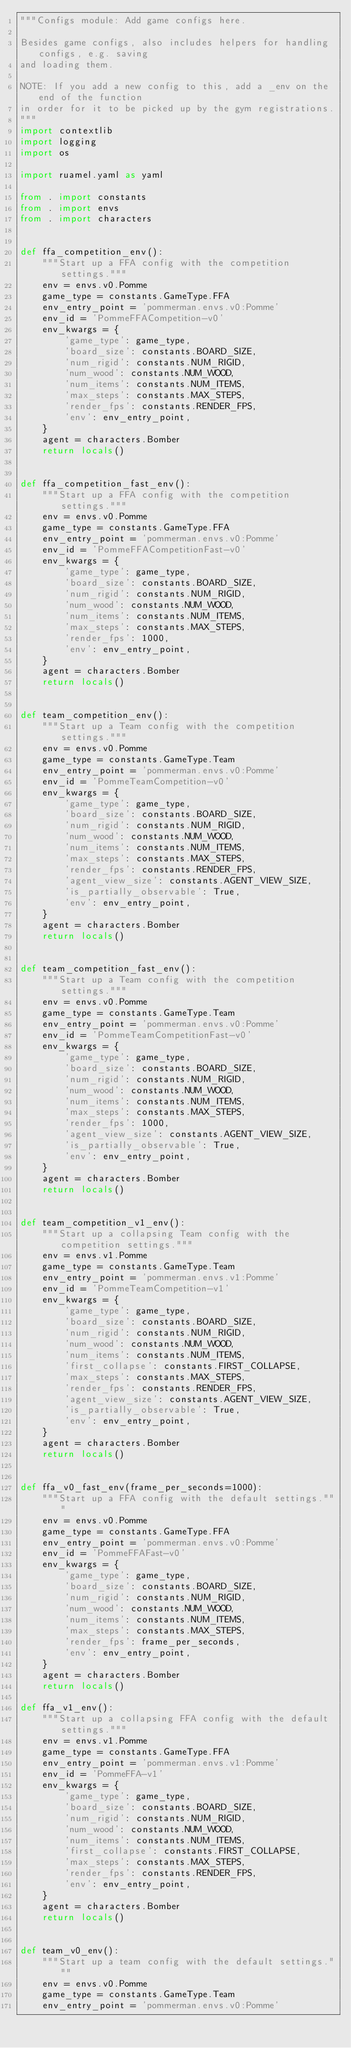<code> <loc_0><loc_0><loc_500><loc_500><_Python_>"""Configs module: Add game configs here.

Besides game configs, also includes helpers for handling configs, e.g. saving
and loading them.

NOTE: If you add a new config to this, add a _env on the end of the function
in order for it to be picked up by the gym registrations.
"""
import contextlib
import logging
import os

import ruamel.yaml as yaml

from . import constants
from . import envs
from . import characters


def ffa_competition_env():
    """Start up a FFA config with the competition settings."""
    env = envs.v0.Pomme
    game_type = constants.GameType.FFA
    env_entry_point = 'pommerman.envs.v0:Pomme'
    env_id = 'PommeFFACompetition-v0'
    env_kwargs = {
        'game_type': game_type,
        'board_size': constants.BOARD_SIZE,
        'num_rigid': constants.NUM_RIGID,
        'num_wood': constants.NUM_WOOD,
        'num_items': constants.NUM_ITEMS,
        'max_steps': constants.MAX_STEPS,
        'render_fps': constants.RENDER_FPS,
        'env': env_entry_point,
    }
    agent = characters.Bomber
    return locals()


def ffa_competition_fast_env():
    """Start up a FFA config with the competition settings."""
    env = envs.v0.Pomme
    game_type = constants.GameType.FFA
    env_entry_point = 'pommerman.envs.v0:Pomme'
    env_id = 'PommeFFACompetitionFast-v0'
    env_kwargs = {
        'game_type': game_type,
        'board_size': constants.BOARD_SIZE,
        'num_rigid': constants.NUM_RIGID,
        'num_wood': constants.NUM_WOOD,
        'num_items': constants.NUM_ITEMS,
        'max_steps': constants.MAX_STEPS,
        'render_fps': 1000,
        'env': env_entry_point,
    }
    agent = characters.Bomber
    return locals()


def team_competition_env():
    """Start up a Team config with the competition settings."""
    env = envs.v0.Pomme
    game_type = constants.GameType.Team
    env_entry_point = 'pommerman.envs.v0:Pomme'
    env_id = 'PommeTeamCompetition-v0'
    env_kwargs = {
        'game_type': game_type,
        'board_size': constants.BOARD_SIZE,
        'num_rigid': constants.NUM_RIGID,
        'num_wood': constants.NUM_WOOD,
        'num_items': constants.NUM_ITEMS,
        'max_steps': constants.MAX_STEPS,
        'render_fps': constants.RENDER_FPS,
        'agent_view_size': constants.AGENT_VIEW_SIZE,
        'is_partially_observable': True,
        'env': env_entry_point,
    }
    agent = characters.Bomber
    return locals()


def team_competition_fast_env():
    """Start up a Team config with the competition settings."""
    env = envs.v0.Pomme
    game_type = constants.GameType.Team
    env_entry_point = 'pommerman.envs.v0:Pomme'
    env_id = 'PommeTeamCompetitionFast-v0'
    env_kwargs = {
        'game_type': game_type,
        'board_size': constants.BOARD_SIZE,
        'num_rigid': constants.NUM_RIGID,
        'num_wood': constants.NUM_WOOD,
        'num_items': constants.NUM_ITEMS,
        'max_steps': constants.MAX_STEPS,
        'render_fps': 1000,
        'agent_view_size': constants.AGENT_VIEW_SIZE,
        'is_partially_observable': True,
        'env': env_entry_point,
    }
    agent = characters.Bomber
    return locals()


def team_competition_v1_env():
    """Start up a collapsing Team config with the competition settings."""
    env = envs.v1.Pomme
    game_type = constants.GameType.Team
    env_entry_point = 'pommerman.envs.v1:Pomme'
    env_id = 'PommeTeamCompetition-v1'
    env_kwargs = {
        'game_type': game_type,
        'board_size': constants.BOARD_SIZE,
        'num_rigid': constants.NUM_RIGID,
        'num_wood': constants.NUM_WOOD,
        'num_items': constants.NUM_ITEMS,
        'first_collapse': constants.FIRST_COLLAPSE,
        'max_steps': constants.MAX_STEPS,
        'render_fps': constants.RENDER_FPS,
        'agent_view_size': constants.AGENT_VIEW_SIZE,
        'is_partially_observable': True,
        'env': env_entry_point,
    }
    agent = characters.Bomber
    return locals()


def ffa_v0_fast_env(frame_per_seconds=1000):
    """Start up a FFA config with the default settings."""
    env = envs.v0.Pomme
    game_type = constants.GameType.FFA
    env_entry_point = 'pommerman.envs.v0:Pomme'
    env_id = 'PommeFFAFast-v0'
    env_kwargs = {
        'game_type': game_type,
        'board_size': constants.BOARD_SIZE,
        'num_rigid': constants.NUM_RIGID,
        'num_wood': constants.NUM_WOOD,
        'num_items': constants.NUM_ITEMS,
        'max_steps': constants.MAX_STEPS,
        'render_fps': frame_per_seconds,
        'env': env_entry_point,
    }
    agent = characters.Bomber
    return locals()

def ffa_v1_env():
    """Start up a collapsing FFA config with the default settings."""
    env = envs.v1.Pomme
    game_type = constants.GameType.FFA
    env_entry_point = 'pommerman.envs.v1:Pomme'
    env_id = 'PommeFFA-v1'
    env_kwargs = {
        'game_type': game_type,
        'board_size': constants.BOARD_SIZE,
        'num_rigid': constants.NUM_RIGID,
        'num_wood': constants.NUM_WOOD,
        'num_items': constants.NUM_ITEMS,
        'first_collapse': constants.FIRST_COLLAPSE,
        'max_steps': constants.MAX_STEPS,
        'render_fps': constants.RENDER_FPS,
        'env': env_entry_point,
    }
    agent = characters.Bomber
    return locals()


def team_v0_env():
    """Start up a team config with the default settings."""
    env = envs.v0.Pomme
    game_type = constants.GameType.Team
    env_entry_point = 'pommerman.envs.v0:Pomme'</code> 